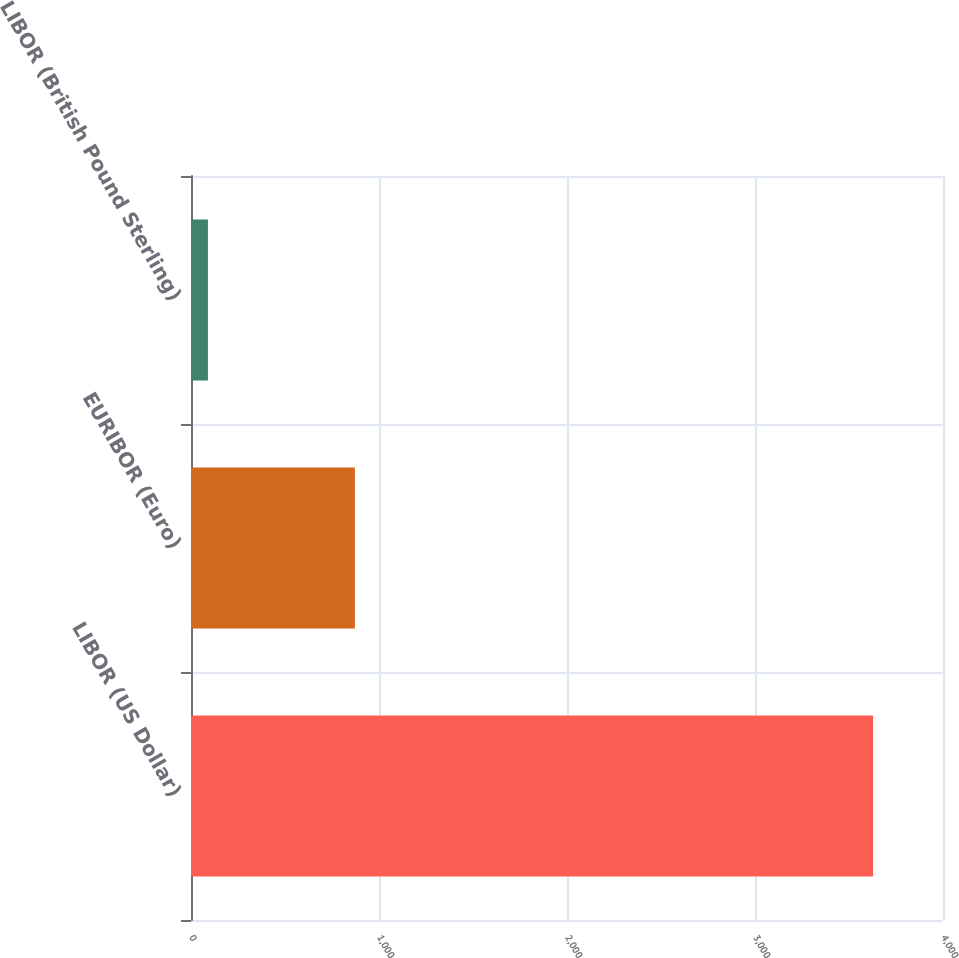Convert chart to OTSL. <chart><loc_0><loc_0><loc_500><loc_500><bar_chart><fcel>LIBOR (US Dollar)<fcel>EURIBOR (Euro)<fcel>LIBOR (British Pound Sterling)<nl><fcel>3628<fcel>872<fcel>90<nl></chart> 